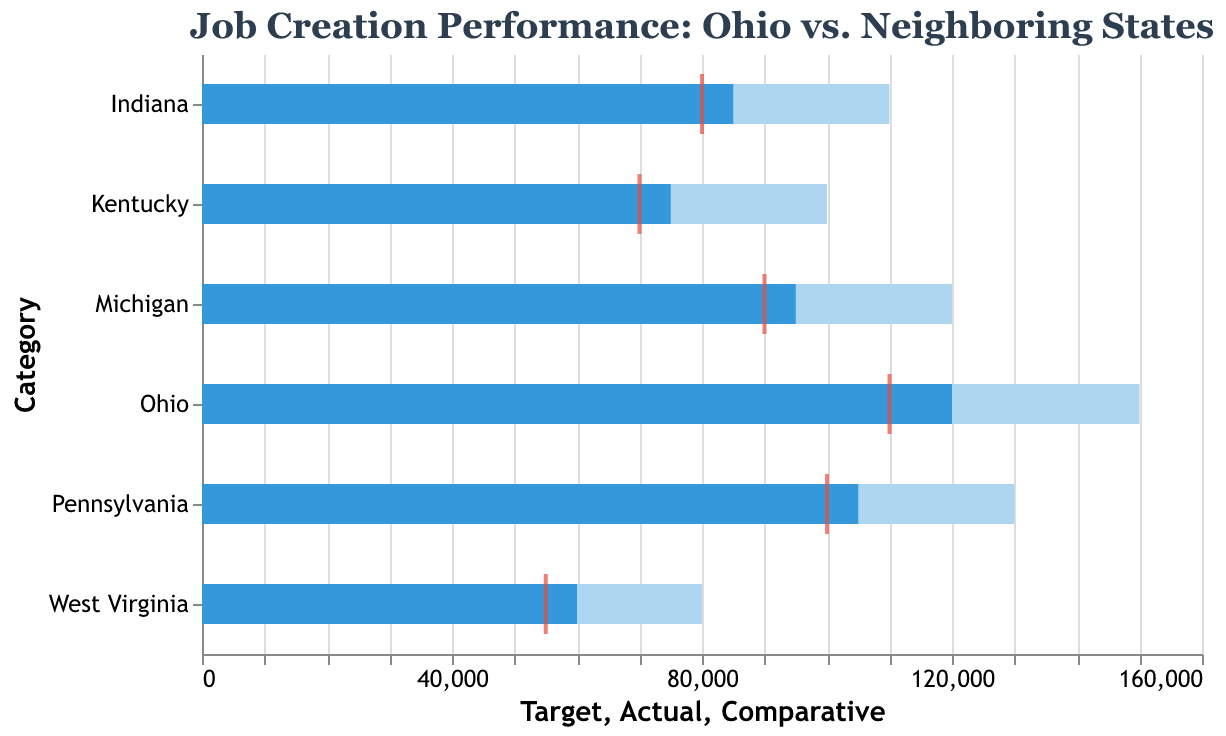What's the title of the chart? The title is clearly stated at the top of the chart. It reads "Job Creation Performance: Ohio vs. Neighboring States". This title succinctly describes what the chart is about.
Answer: Job Creation Performance: Ohio vs. Neighboring States Which state has the highest 'Actual' job creation figure? By comparing the 'Actual' job creation values represented by the bars, Ohio has the highest 'Actual' figure at 120,000. This bar is the longest compared to the others.
Answer: Ohio What is the target job creation figure for Pennsylvania? Looking at the lighter-colored bar for Pennsylvania, it touches the 130,000 mark on the x-axis, indicating the target figure.
Answer: 130,000 How does Ohio's 'Actual' job creation compare to its target? To find how Ohio's 'Actual' job creation compares to its target, we look at the 'Actual' value of 120,000 and the 'Target' value of 150,000. Subtracting these gives us 30,000. Ohio is 30,000 jobs short of the target.
Answer: 30,000 short Which state has the smallest difference between its 'Actual' and 'Comparative' figures? To determine this, we look at the difference between the 'Actual' and 'Comparative' values for each state. Ohio: 10,000, Pennsylvania: 5,000, Michigan: 5,000, Indiana: 5,000, Kentucky: 5,000, West Virginia: 5,000. All states except Ohio have a difference of 5,000.
Answer: Pennsylvania, Michigan, Indiana, Kentucky, West Virginia How many states have an 'Actual' job creation figure higher than their 'Comparative' figure? By evaluating each state's 'Actual' and 'Comparative' values, we see that Ohio, Pennsylvania, Indiana, Kentucky, and West Virginia have 'Actual' figures higher than their 'Comparative' values.
Answer: 5 states What is the range of the 'Actual' job creation figures among the states? The range is determined by subtracting the smallest 'Actual' value (60,000 for West Virginia) from the largest 'Actual' value (120,000 for Ohio), resulting in a range of 60,000.
Answer: 60,000 Which state has the highest 'Comparative' job creation figure? The red tick marks indicate the 'Comparative' job creation figures. By comparing them, Ohio has the highest 'Comparative' figure of 110,000.
Answer: Ohio How does Ohio's performance compare to Michigan's in terms of 'Actual' job creation? Ohio's 'Actual' job creation figure is 120,000, while Michigan's is 95,000. Ohio has created 25,000 more jobs than Michigan in 'Actual' terms.
Answer: 25,000 more What is the target job creation figure for the state with the lowest 'Actual' job creation figure? West Virginia has the lowest 'Actual' job creation figure at 60,000. Looking at the lighter-colored bar for West Virginia, the target job creation figure is 80,000.
Answer: 80,000 